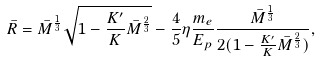<formula> <loc_0><loc_0><loc_500><loc_500>\bar { R } = \bar { M } ^ { \frac { 1 } { 3 } } \sqrt { 1 - \frac { K ^ { \prime } } { K } \bar { M } ^ { \frac { 2 } { 3 } } } - \frac { 4 } { 5 } \eta \frac { m _ { e } } { E _ { p } } \frac { \bar { M } ^ { \frac { 1 } { 3 } } } { 2 ( 1 - \frac { K ^ { \prime } } { K } \bar { M } ^ { \frac { 2 } { 3 } } ) } ,</formula> 